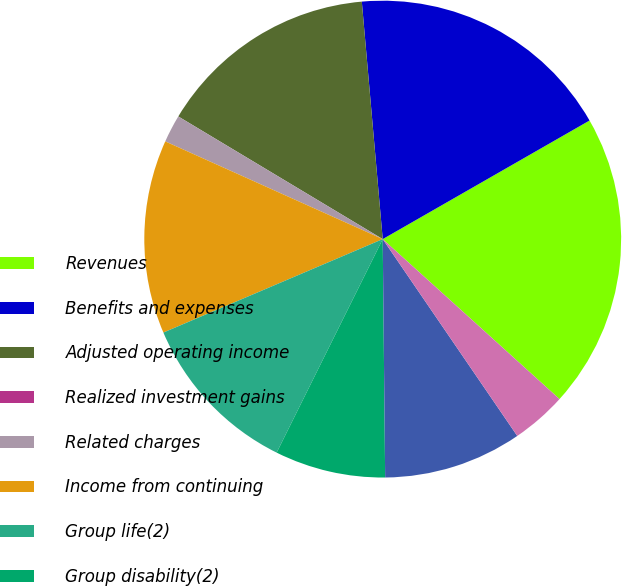Convert chart. <chart><loc_0><loc_0><loc_500><loc_500><pie_chart><fcel>Revenues<fcel>Benefits and expenses<fcel>Adjusted operating income<fcel>Realized investment gains<fcel>Related charges<fcel>Income from continuing<fcel>Group life(2)<fcel>Group disability(2)<fcel>Total group insurance(2)<fcel>Group life<nl><fcel>19.99%<fcel>18.11%<fcel>15.0%<fcel>0.0%<fcel>1.88%<fcel>13.13%<fcel>11.25%<fcel>7.5%<fcel>9.38%<fcel>3.75%<nl></chart> 